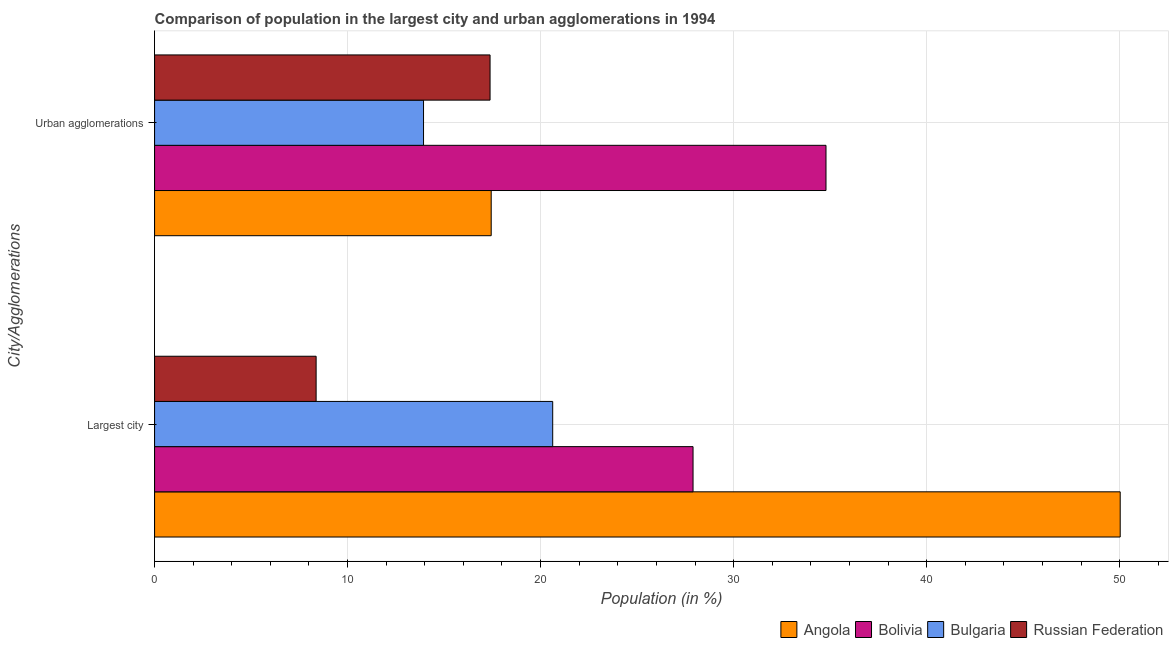Are the number of bars per tick equal to the number of legend labels?
Offer a very short reply. Yes. How many bars are there on the 2nd tick from the top?
Offer a terse response. 4. What is the label of the 2nd group of bars from the top?
Make the answer very short. Largest city. What is the population in urban agglomerations in Angola?
Offer a terse response. 17.44. Across all countries, what is the maximum population in the largest city?
Your response must be concise. 50.03. Across all countries, what is the minimum population in urban agglomerations?
Offer a very short reply. 13.94. In which country was the population in the largest city maximum?
Provide a succinct answer. Angola. In which country was the population in urban agglomerations minimum?
Offer a very short reply. Bulgaria. What is the total population in the largest city in the graph?
Provide a short and direct response. 106.93. What is the difference between the population in the largest city in Angola and that in Bulgaria?
Offer a terse response. 29.4. What is the difference between the population in the largest city in Angola and the population in urban agglomerations in Russian Federation?
Ensure brevity in your answer.  32.65. What is the average population in urban agglomerations per country?
Offer a very short reply. 20.89. What is the difference between the population in urban agglomerations and population in the largest city in Angola?
Your answer should be very brief. -32.59. In how many countries, is the population in the largest city greater than 12 %?
Offer a terse response. 3. What is the ratio of the population in the largest city in Bulgaria to that in Russian Federation?
Provide a short and direct response. 2.46. Is the population in urban agglomerations in Bolivia less than that in Bulgaria?
Provide a succinct answer. No. What does the 1st bar from the top in Largest city represents?
Provide a succinct answer. Russian Federation. What does the 1st bar from the bottom in Largest city represents?
Your answer should be very brief. Angola. How many bars are there?
Offer a terse response. 8. Are all the bars in the graph horizontal?
Offer a terse response. Yes. How many countries are there in the graph?
Provide a short and direct response. 4. What is the title of the graph?
Your response must be concise. Comparison of population in the largest city and urban agglomerations in 1994. What is the label or title of the Y-axis?
Offer a terse response. City/Agglomerations. What is the Population (in %) in Angola in Largest city?
Provide a short and direct response. 50.03. What is the Population (in %) of Bolivia in Largest city?
Provide a short and direct response. 27.9. What is the Population (in %) in Bulgaria in Largest city?
Give a very brief answer. 20.63. What is the Population (in %) of Russian Federation in Largest city?
Your response must be concise. 8.37. What is the Population (in %) of Angola in Urban agglomerations?
Provide a short and direct response. 17.44. What is the Population (in %) of Bolivia in Urban agglomerations?
Your response must be concise. 34.79. What is the Population (in %) of Bulgaria in Urban agglomerations?
Offer a terse response. 13.94. What is the Population (in %) in Russian Federation in Urban agglomerations?
Keep it short and to the point. 17.38. Across all City/Agglomerations, what is the maximum Population (in %) of Angola?
Keep it short and to the point. 50.03. Across all City/Agglomerations, what is the maximum Population (in %) in Bolivia?
Offer a terse response. 34.79. Across all City/Agglomerations, what is the maximum Population (in %) of Bulgaria?
Keep it short and to the point. 20.63. Across all City/Agglomerations, what is the maximum Population (in %) of Russian Federation?
Provide a succinct answer. 17.38. Across all City/Agglomerations, what is the minimum Population (in %) of Angola?
Provide a short and direct response. 17.44. Across all City/Agglomerations, what is the minimum Population (in %) in Bolivia?
Provide a short and direct response. 27.9. Across all City/Agglomerations, what is the minimum Population (in %) in Bulgaria?
Ensure brevity in your answer.  13.94. Across all City/Agglomerations, what is the minimum Population (in %) in Russian Federation?
Give a very brief answer. 8.37. What is the total Population (in %) of Angola in the graph?
Provide a short and direct response. 67.47. What is the total Population (in %) in Bolivia in the graph?
Make the answer very short. 62.69. What is the total Population (in %) of Bulgaria in the graph?
Make the answer very short. 34.56. What is the total Population (in %) in Russian Federation in the graph?
Provide a succinct answer. 25.75. What is the difference between the Population (in %) of Angola in Largest city and that in Urban agglomerations?
Provide a short and direct response. 32.59. What is the difference between the Population (in %) of Bolivia in Largest city and that in Urban agglomerations?
Make the answer very short. -6.89. What is the difference between the Population (in %) in Bulgaria in Largest city and that in Urban agglomerations?
Your answer should be very brief. 6.69. What is the difference between the Population (in %) in Russian Federation in Largest city and that in Urban agglomerations?
Provide a short and direct response. -9.01. What is the difference between the Population (in %) in Angola in Largest city and the Population (in %) in Bolivia in Urban agglomerations?
Your answer should be compact. 15.24. What is the difference between the Population (in %) of Angola in Largest city and the Population (in %) of Bulgaria in Urban agglomerations?
Give a very brief answer. 36.1. What is the difference between the Population (in %) of Angola in Largest city and the Population (in %) of Russian Federation in Urban agglomerations?
Your response must be concise. 32.65. What is the difference between the Population (in %) in Bolivia in Largest city and the Population (in %) in Bulgaria in Urban agglomerations?
Give a very brief answer. 13.96. What is the difference between the Population (in %) in Bolivia in Largest city and the Population (in %) in Russian Federation in Urban agglomerations?
Make the answer very short. 10.52. What is the difference between the Population (in %) in Bulgaria in Largest city and the Population (in %) in Russian Federation in Urban agglomerations?
Your answer should be very brief. 3.25. What is the average Population (in %) of Angola per City/Agglomerations?
Offer a terse response. 33.74. What is the average Population (in %) of Bolivia per City/Agglomerations?
Keep it short and to the point. 31.34. What is the average Population (in %) in Bulgaria per City/Agglomerations?
Make the answer very short. 17.28. What is the average Population (in %) of Russian Federation per City/Agglomerations?
Ensure brevity in your answer.  12.88. What is the difference between the Population (in %) in Angola and Population (in %) in Bolivia in Largest city?
Offer a terse response. 22.13. What is the difference between the Population (in %) of Angola and Population (in %) of Bulgaria in Largest city?
Give a very brief answer. 29.4. What is the difference between the Population (in %) in Angola and Population (in %) in Russian Federation in Largest city?
Give a very brief answer. 41.66. What is the difference between the Population (in %) in Bolivia and Population (in %) in Bulgaria in Largest city?
Give a very brief answer. 7.27. What is the difference between the Population (in %) in Bolivia and Population (in %) in Russian Federation in Largest city?
Your response must be concise. 19.53. What is the difference between the Population (in %) of Bulgaria and Population (in %) of Russian Federation in Largest city?
Make the answer very short. 12.26. What is the difference between the Population (in %) in Angola and Population (in %) in Bolivia in Urban agglomerations?
Give a very brief answer. -17.35. What is the difference between the Population (in %) of Angola and Population (in %) of Bulgaria in Urban agglomerations?
Offer a terse response. 3.51. What is the difference between the Population (in %) of Angola and Population (in %) of Russian Federation in Urban agglomerations?
Ensure brevity in your answer.  0.06. What is the difference between the Population (in %) of Bolivia and Population (in %) of Bulgaria in Urban agglomerations?
Give a very brief answer. 20.85. What is the difference between the Population (in %) of Bolivia and Population (in %) of Russian Federation in Urban agglomerations?
Offer a very short reply. 17.41. What is the difference between the Population (in %) in Bulgaria and Population (in %) in Russian Federation in Urban agglomerations?
Ensure brevity in your answer.  -3.45. What is the ratio of the Population (in %) of Angola in Largest city to that in Urban agglomerations?
Offer a very short reply. 2.87. What is the ratio of the Population (in %) of Bolivia in Largest city to that in Urban agglomerations?
Provide a succinct answer. 0.8. What is the ratio of the Population (in %) of Bulgaria in Largest city to that in Urban agglomerations?
Offer a terse response. 1.48. What is the ratio of the Population (in %) of Russian Federation in Largest city to that in Urban agglomerations?
Your answer should be compact. 0.48. What is the difference between the highest and the second highest Population (in %) in Angola?
Ensure brevity in your answer.  32.59. What is the difference between the highest and the second highest Population (in %) in Bolivia?
Keep it short and to the point. 6.89. What is the difference between the highest and the second highest Population (in %) in Bulgaria?
Give a very brief answer. 6.69. What is the difference between the highest and the second highest Population (in %) in Russian Federation?
Offer a terse response. 9.01. What is the difference between the highest and the lowest Population (in %) in Angola?
Your response must be concise. 32.59. What is the difference between the highest and the lowest Population (in %) of Bolivia?
Your response must be concise. 6.89. What is the difference between the highest and the lowest Population (in %) in Bulgaria?
Make the answer very short. 6.69. What is the difference between the highest and the lowest Population (in %) of Russian Federation?
Provide a short and direct response. 9.01. 